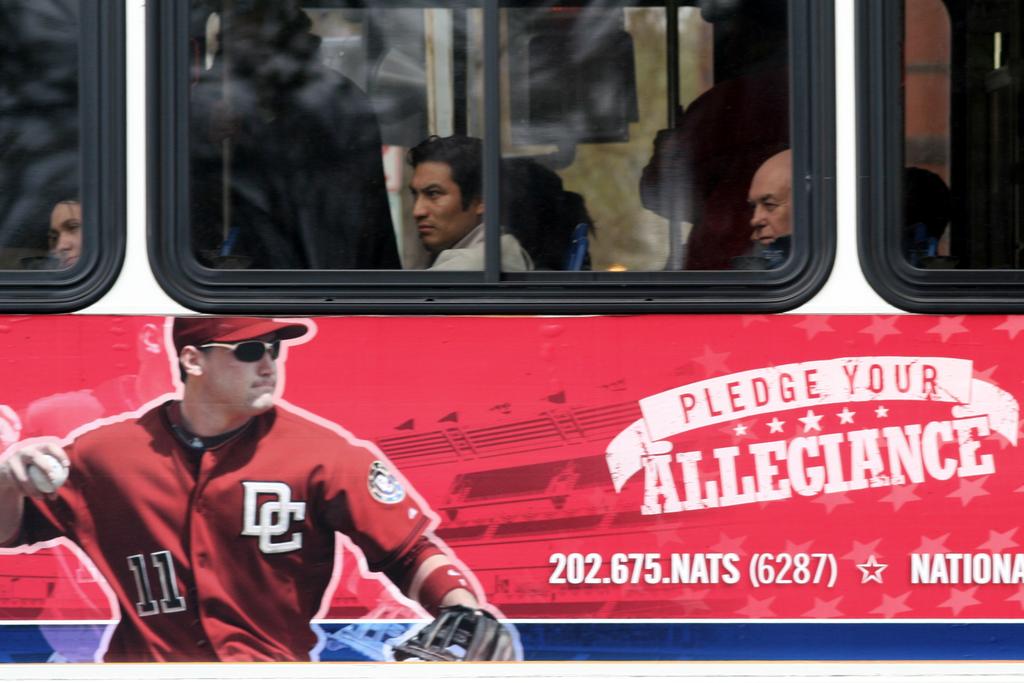What player number is on the pitcher's jersey?
Your response must be concise. 11. What should you pledge?
Your answer should be compact. Allegiance. 